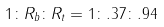Convert formula to latex. <formula><loc_0><loc_0><loc_500><loc_500>1 \colon { R _ { b } } \colon { R _ { t } } = 1 \colon . 3 7 \colon . 9 4</formula> 